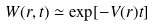<formula> <loc_0><loc_0><loc_500><loc_500>W ( r , t ) \simeq \exp [ - V ( r ) t ]</formula> 